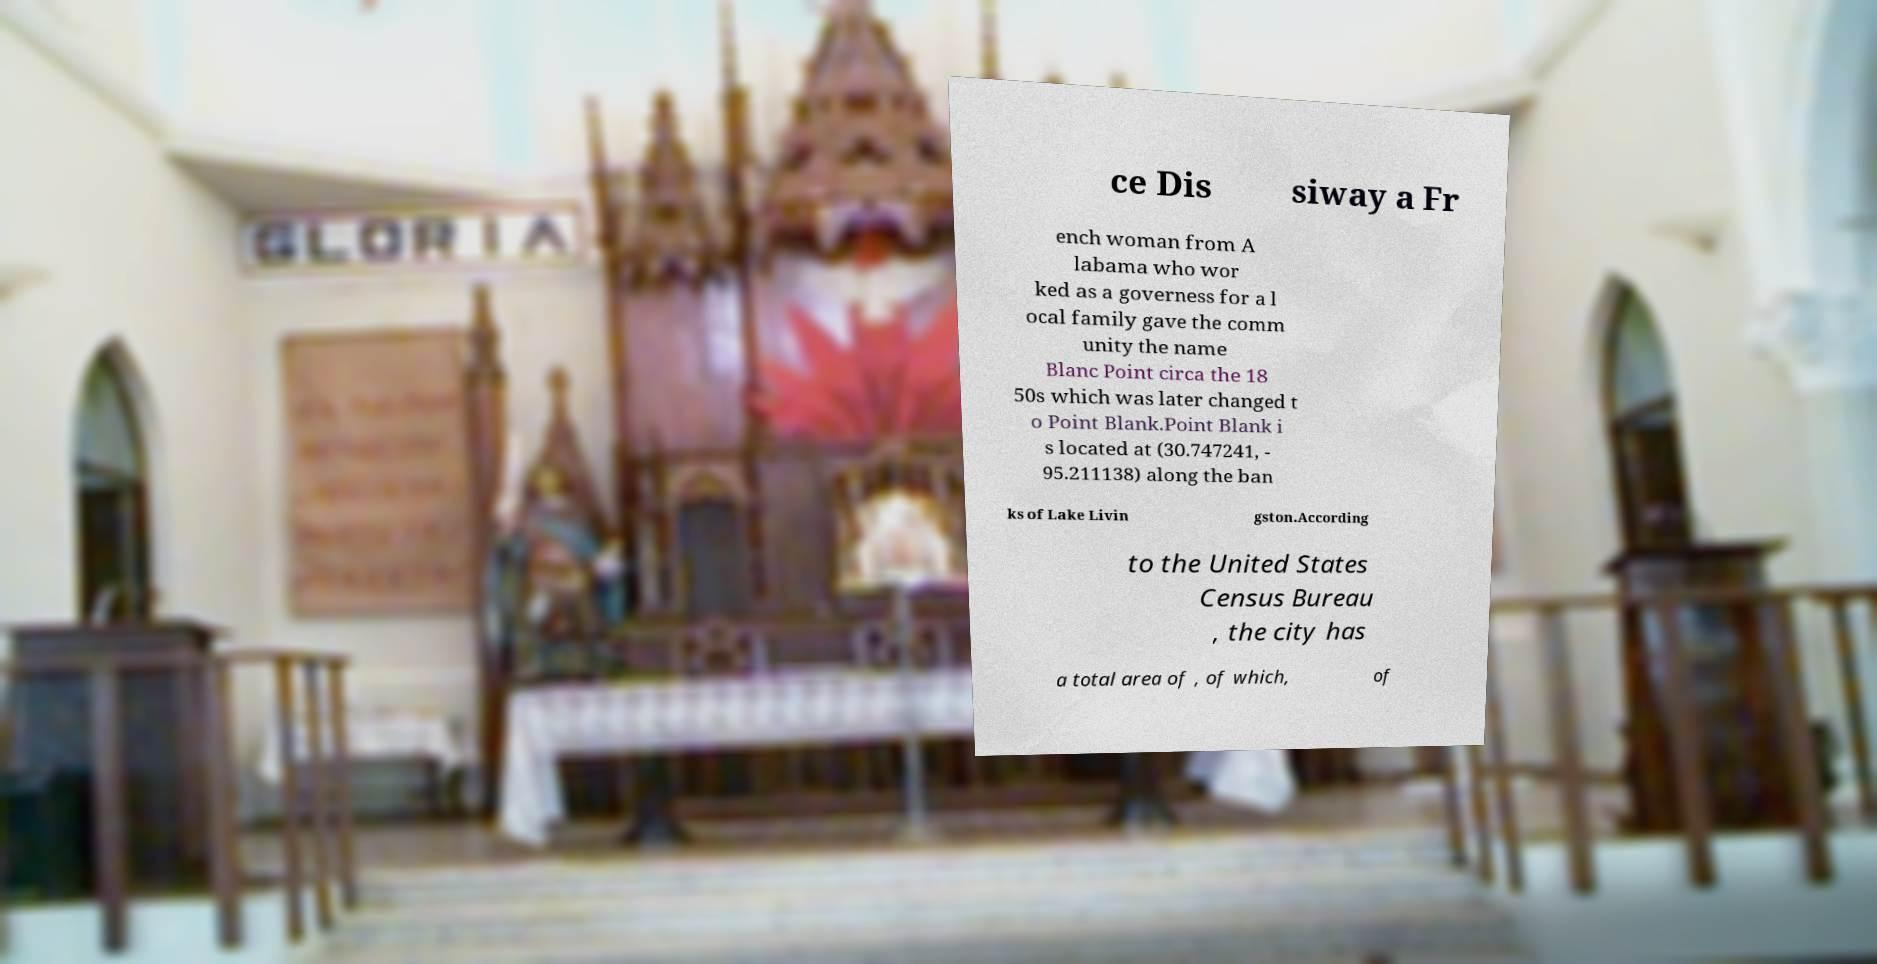What messages or text are displayed in this image? I need them in a readable, typed format. ce Dis siway a Fr ench woman from A labama who wor ked as a governess for a l ocal family gave the comm unity the name Blanc Point circa the 18 50s which was later changed t o Point Blank.Point Blank i s located at (30.747241, - 95.211138) along the ban ks of Lake Livin gston.According to the United States Census Bureau , the city has a total area of , of which, of 